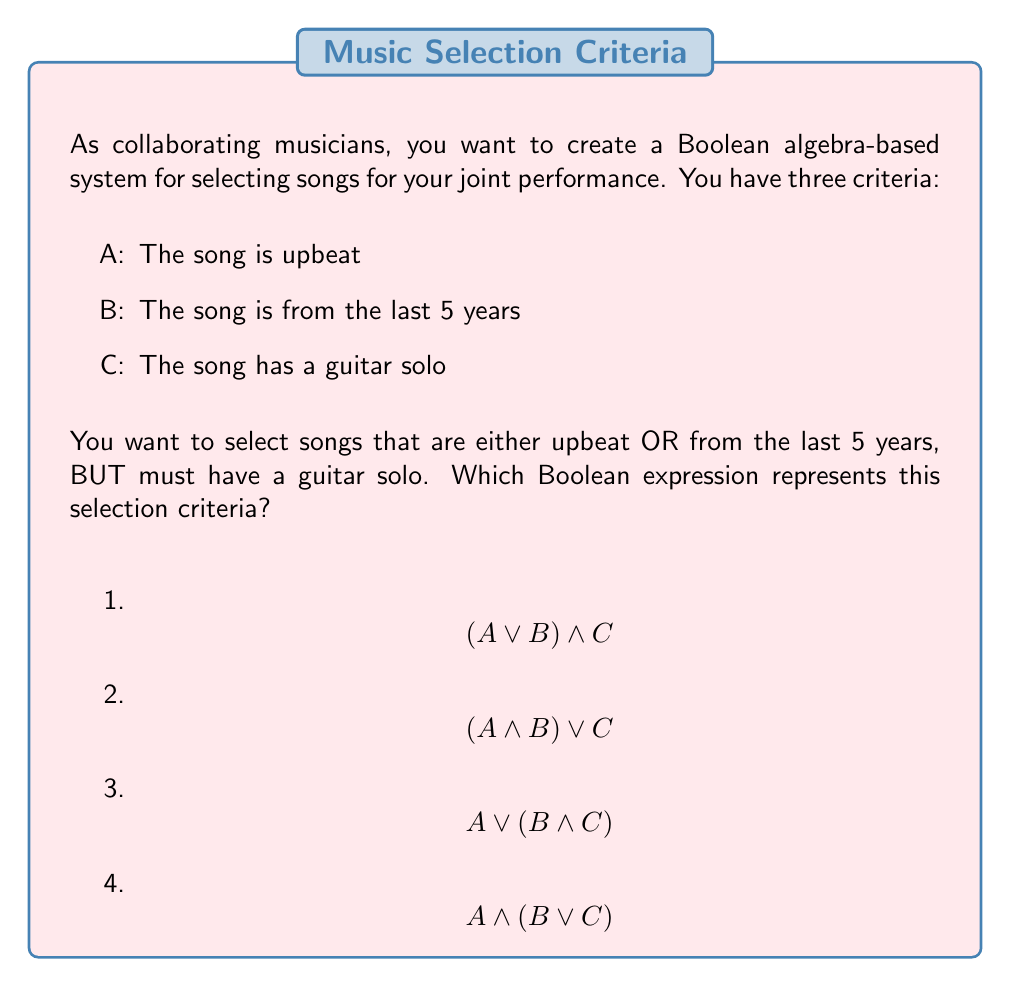Can you answer this question? Let's break down the problem step-by-step:

1) First, let's understand what each variable represents:
   A: The song is upbeat
   B: The song is from the last 5 years
   C: The song has a guitar solo

2) Now, let's analyze the criteria:
   - The song should be either upbeat OR from the last 5 years
   - The song MUST have a guitar solo

3) Let's express this in Boolean terms:
   - "either upbeat OR from the last 5 years" is represented by $$(A \lor B)$$
   - "MUST have a guitar solo" means we AND this with C

4) Therefore, the correct Boolean expression is:
   $$(A \lor B) \land C$$

5) This expression means:
   (The song is upbeat OR the song is from the last 5 years) AND the song has a guitar solo

6) Checking the options:
   1) $$(A \lor B) \land C$$ - This matches our analysis
   2) $$(A \land B) \lor C$$ - This would select songs that are both upbeat AND recent, OR have a guitar solo (not matching our criteria)
   3) $$A \lor (B \land C)$$ - This would select upbeat songs, OR recent songs with a guitar solo (not matching our criteria)
   4) $$A \land (B \lor C)$$ - This would select upbeat songs that are either recent OR have a guitar solo (not matching our criteria)

Therefore, option 1 is the correct answer.
Answer: $$(A \lor B) \land C$$ 